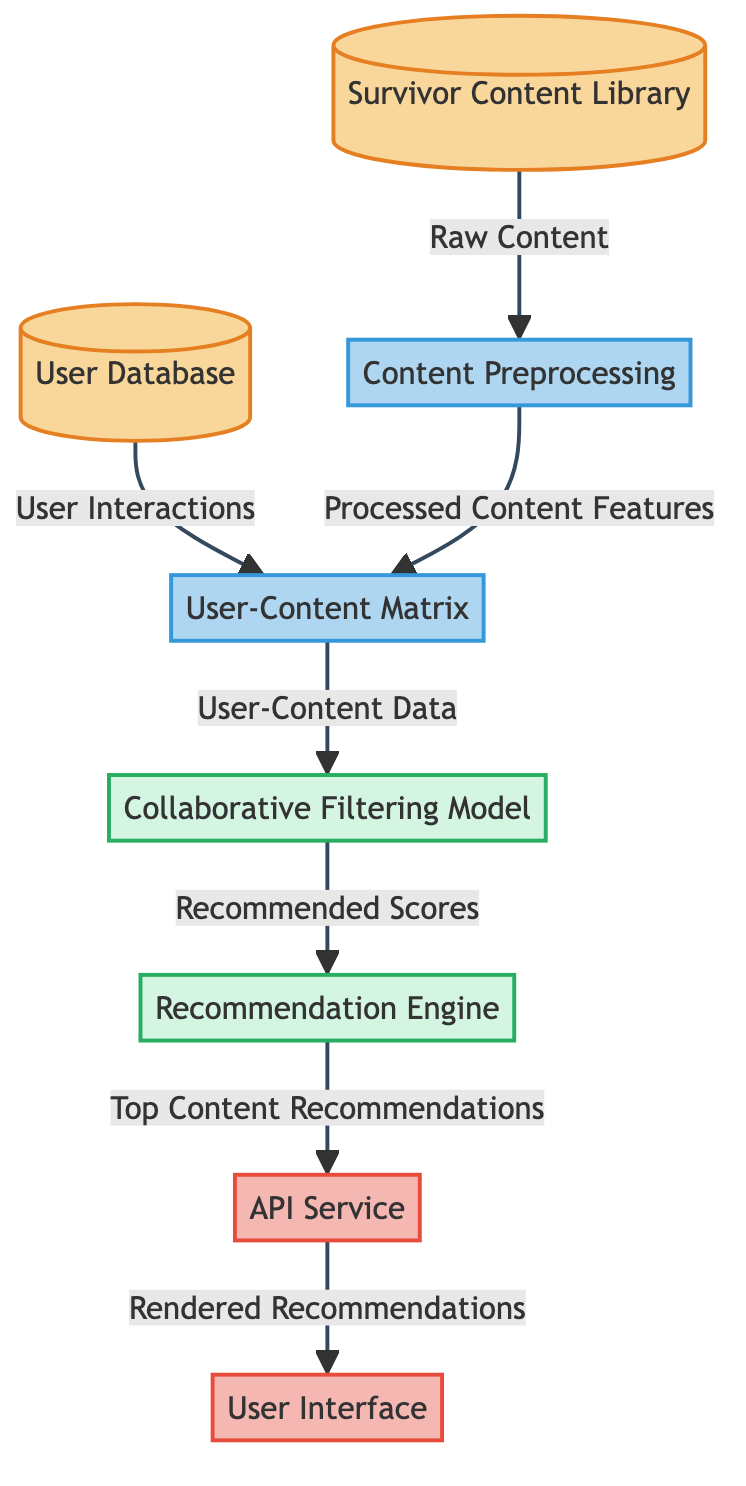What is the first node in the diagram? The first node in the diagram represents the "User Database", which is where user interactions are stored.
Answer: User Database How many main processes are depicted in the diagram? The diagram shows three main processes: "Content Preprocessing", "User-Content Matrix", and "Collaborative Filtering Model".
Answer: Three What type of data flows from the "User Database" to the "User-Content Matrix"? The data flowing from the "User Database" to the "User-Content Matrix" is "User Interactions", which indicates how users engage with the content.
Answer: User Interactions Which node collects "Top Content Recommendations"? The "Recommendation Engine" node collects "Top Content Recommendations", which are generated based on the scores from the collaborative filtering model.
Answer: Recommendation Engine What is the final output in the diagram? The final output of the diagram is "Rendered Recommendations", which are shown to the user through the user interface.
Answer: Rendered Recommendations What is the purpose of the "API Service" node in the diagram? The "API Service" node acts as an intermediary that takes the output from the "Recommendation Engine" and serves it to the "User Interface".
Answer: Intermediary service Which two nodes are in the 'database' class in the diagram? The two nodes in the 'database' class are "User Database" and "Survivor Content Library", both of which store essential data for the automated content recommendation process.
Answer: User Database, Survivor Content Library What role does the "Collaborative Filtering Model" play in the content recommendation? The "Collaborative Filtering Model" computes "Recommended Scores" based on the "User-Content Data", which is essential for determining which content to recommend to users.
Answer: Computes recommended scores How is the content processed before it reaches the "User-Content Matrix"? Before reaching the "User-Content Matrix", the content goes through "Content Preprocessing", where it is transformed into processed content features suitable for analysis.
Answer: Content Preprocessing 